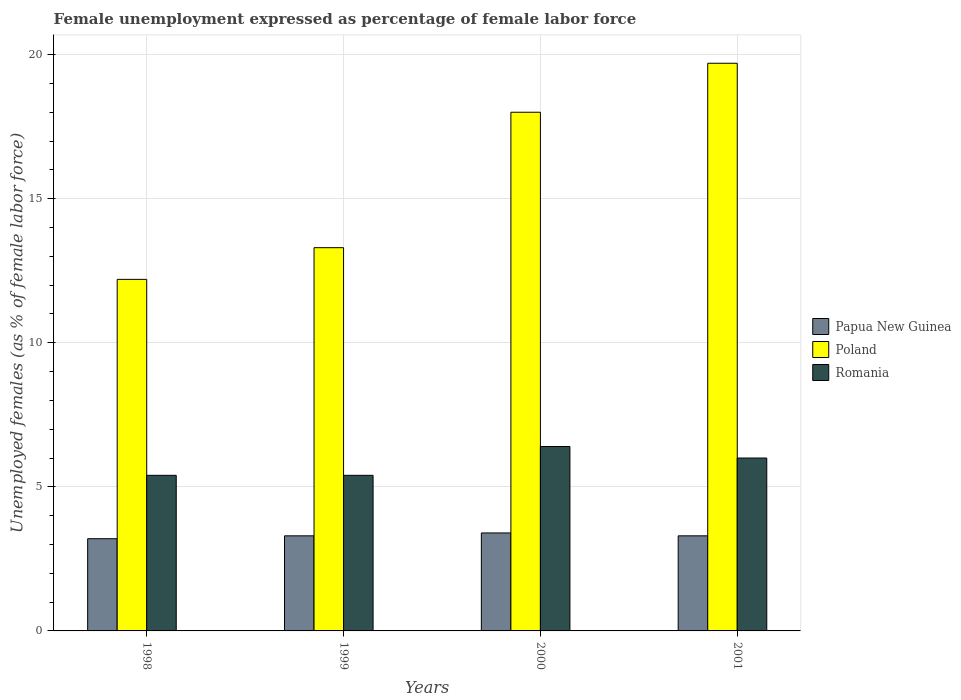How many different coloured bars are there?
Keep it short and to the point. 3. How many groups of bars are there?
Provide a succinct answer. 4. Are the number of bars on each tick of the X-axis equal?
Offer a very short reply. Yes. How many bars are there on the 2nd tick from the right?
Your answer should be very brief. 3. What is the label of the 1st group of bars from the left?
Give a very brief answer. 1998. In how many cases, is the number of bars for a given year not equal to the number of legend labels?
Your response must be concise. 0. What is the unemployment in females in in Papua New Guinea in 2001?
Your response must be concise. 3.3. Across all years, what is the maximum unemployment in females in in Romania?
Provide a short and direct response. 6.4. Across all years, what is the minimum unemployment in females in in Poland?
Offer a terse response. 12.2. In which year was the unemployment in females in in Romania maximum?
Ensure brevity in your answer.  2000. In which year was the unemployment in females in in Papua New Guinea minimum?
Provide a short and direct response. 1998. What is the total unemployment in females in in Papua New Guinea in the graph?
Offer a terse response. 13.2. What is the difference between the unemployment in females in in Romania in 1999 and that in 2001?
Your answer should be very brief. -0.6. What is the difference between the unemployment in females in in Romania in 1998 and the unemployment in females in in Papua New Guinea in 1999?
Provide a succinct answer. 2.1. What is the average unemployment in females in in Poland per year?
Give a very brief answer. 15.8. In the year 1999, what is the difference between the unemployment in females in in Poland and unemployment in females in in Papua New Guinea?
Provide a succinct answer. 10. What is the ratio of the unemployment in females in in Papua New Guinea in 1999 to that in 2000?
Keep it short and to the point. 0.97. Is the unemployment in females in in Poland in 1998 less than that in 1999?
Ensure brevity in your answer.  Yes. What is the difference between the highest and the second highest unemployment in females in in Poland?
Your response must be concise. 1.7. What is the difference between the highest and the lowest unemployment in females in in Romania?
Make the answer very short. 1. In how many years, is the unemployment in females in in Papua New Guinea greater than the average unemployment in females in in Papua New Guinea taken over all years?
Make the answer very short. 1. Is the sum of the unemployment in females in in Papua New Guinea in 2000 and 2001 greater than the maximum unemployment in females in in Romania across all years?
Provide a short and direct response. Yes. What does the 2nd bar from the left in 1999 represents?
Provide a succinct answer. Poland. What does the 1st bar from the right in 1998 represents?
Your response must be concise. Romania. What is the difference between two consecutive major ticks on the Y-axis?
Give a very brief answer. 5. Where does the legend appear in the graph?
Provide a short and direct response. Center right. How are the legend labels stacked?
Offer a very short reply. Vertical. What is the title of the graph?
Your response must be concise. Female unemployment expressed as percentage of female labor force. What is the label or title of the X-axis?
Provide a succinct answer. Years. What is the label or title of the Y-axis?
Your response must be concise. Unemployed females (as % of female labor force). What is the Unemployed females (as % of female labor force) of Papua New Guinea in 1998?
Provide a succinct answer. 3.2. What is the Unemployed females (as % of female labor force) in Poland in 1998?
Provide a short and direct response. 12.2. What is the Unemployed females (as % of female labor force) in Romania in 1998?
Your answer should be compact. 5.4. What is the Unemployed females (as % of female labor force) of Papua New Guinea in 1999?
Ensure brevity in your answer.  3.3. What is the Unemployed females (as % of female labor force) in Poland in 1999?
Offer a very short reply. 13.3. What is the Unemployed females (as % of female labor force) in Romania in 1999?
Make the answer very short. 5.4. What is the Unemployed females (as % of female labor force) of Papua New Guinea in 2000?
Your answer should be compact. 3.4. What is the Unemployed females (as % of female labor force) in Romania in 2000?
Give a very brief answer. 6.4. What is the Unemployed females (as % of female labor force) in Papua New Guinea in 2001?
Offer a very short reply. 3.3. What is the Unemployed females (as % of female labor force) of Poland in 2001?
Give a very brief answer. 19.7. What is the Unemployed females (as % of female labor force) of Romania in 2001?
Provide a short and direct response. 6. Across all years, what is the maximum Unemployed females (as % of female labor force) in Papua New Guinea?
Your answer should be compact. 3.4. Across all years, what is the maximum Unemployed females (as % of female labor force) of Poland?
Provide a short and direct response. 19.7. Across all years, what is the maximum Unemployed females (as % of female labor force) in Romania?
Your response must be concise. 6.4. Across all years, what is the minimum Unemployed females (as % of female labor force) of Papua New Guinea?
Ensure brevity in your answer.  3.2. Across all years, what is the minimum Unemployed females (as % of female labor force) of Poland?
Your answer should be very brief. 12.2. Across all years, what is the minimum Unemployed females (as % of female labor force) in Romania?
Your answer should be compact. 5.4. What is the total Unemployed females (as % of female labor force) of Papua New Guinea in the graph?
Your answer should be compact. 13.2. What is the total Unemployed females (as % of female labor force) of Poland in the graph?
Your response must be concise. 63.2. What is the total Unemployed females (as % of female labor force) of Romania in the graph?
Provide a short and direct response. 23.2. What is the difference between the Unemployed females (as % of female labor force) in Papua New Guinea in 1998 and that in 1999?
Provide a short and direct response. -0.1. What is the difference between the Unemployed females (as % of female labor force) in Poland in 1998 and that in 1999?
Ensure brevity in your answer.  -1.1. What is the difference between the Unemployed females (as % of female labor force) in Papua New Guinea in 1998 and that in 2000?
Offer a very short reply. -0.2. What is the difference between the Unemployed females (as % of female labor force) in Poland in 1998 and that in 2000?
Provide a short and direct response. -5.8. What is the difference between the Unemployed females (as % of female labor force) in Papua New Guinea in 1998 and that in 2001?
Make the answer very short. -0.1. What is the difference between the Unemployed females (as % of female labor force) of Poland in 1998 and that in 2001?
Provide a short and direct response. -7.5. What is the difference between the Unemployed females (as % of female labor force) of Romania in 1998 and that in 2001?
Offer a very short reply. -0.6. What is the difference between the Unemployed females (as % of female labor force) in Papua New Guinea in 1999 and that in 2000?
Ensure brevity in your answer.  -0.1. What is the difference between the Unemployed females (as % of female labor force) in Papua New Guinea in 1999 and that in 2001?
Your answer should be compact. 0. What is the difference between the Unemployed females (as % of female labor force) of Poland in 1999 and that in 2001?
Offer a terse response. -6.4. What is the difference between the Unemployed females (as % of female labor force) of Romania in 1999 and that in 2001?
Keep it short and to the point. -0.6. What is the difference between the Unemployed females (as % of female labor force) in Papua New Guinea in 2000 and that in 2001?
Your answer should be very brief. 0.1. What is the difference between the Unemployed females (as % of female labor force) of Poland in 1998 and the Unemployed females (as % of female labor force) of Romania in 1999?
Provide a succinct answer. 6.8. What is the difference between the Unemployed females (as % of female labor force) of Papua New Guinea in 1998 and the Unemployed females (as % of female labor force) of Poland in 2000?
Your response must be concise. -14.8. What is the difference between the Unemployed females (as % of female labor force) in Papua New Guinea in 1998 and the Unemployed females (as % of female labor force) in Poland in 2001?
Keep it short and to the point. -16.5. What is the difference between the Unemployed females (as % of female labor force) in Poland in 1998 and the Unemployed females (as % of female labor force) in Romania in 2001?
Provide a succinct answer. 6.2. What is the difference between the Unemployed females (as % of female labor force) of Papua New Guinea in 1999 and the Unemployed females (as % of female labor force) of Poland in 2000?
Offer a terse response. -14.7. What is the difference between the Unemployed females (as % of female labor force) of Papua New Guinea in 1999 and the Unemployed females (as % of female labor force) of Romania in 2000?
Make the answer very short. -3.1. What is the difference between the Unemployed females (as % of female labor force) in Poland in 1999 and the Unemployed females (as % of female labor force) in Romania in 2000?
Make the answer very short. 6.9. What is the difference between the Unemployed females (as % of female labor force) of Papua New Guinea in 1999 and the Unemployed females (as % of female labor force) of Poland in 2001?
Your answer should be very brief. -16.4. What is the difference between the Unemployed females (as % of female labor force) in Papua New Guinea in 1999 and the Unemployed females (as % of female labor force) in Romania in 2001?
Provide a short and direct response. -2.7. What is the difference between the Unemployed females (as % of female labor force) of Papua New Guinea in 2000 and the Unemployed females (as % of female labor force) of Poland in 2001?
Offer a very short reply. -16.3. What is the average Unemployed females (as % of female labor force) in Poland per year?
Keep it short and to the point. 15.8. What is the average Unemployed females (as % of female labor force) in Romania per year?
Your answer should be very brief. 5.8. In the year 1998, what is the difference between the Unemployed females (as % of female labor force) of Papua New Guinea and Unemployed females (as % of female labor force) of Romania?
Give a very brief answer. -2.2. In the year 2000, what is the difference between the Unemployed females (as % of female labor force) of Papua New Guinea and Unemployed females (as % of female labor force) of Poland?
Your response must be concise. -14.6. In the year 2000, what is the difference between the Unemployed females (as % of female labor force) of Papua New Guinea and Unemployed females (as % of female labor force) of Romania?
Make the answer very short. -3. In the year 2000, what is the difference between the Unemployed females (as % of female labor force) in Poland and Unemployed females (as % of female labor force) in Romania?
Keep it short and to the point. 11.6. In the year 2001, what is the difference between the Unemployed females (as % of female labor force) in Papua New Guinea and Unemployed females (as % of female labor force) in Poland?
Give a very brief answer. -16.4. What is the ratio of the Unemployed females (as % of female labor force) of Papua New Guinea in 1998 to that in 1999?
Make the answer very short. 0.97. What is the ratio of the Unemployed females (as % of female labor force) of Poland in 1998 to that in 1999?
Provide a succinct answer. 0.92. What is the ratio of the Unemployed females (as % of female labor force) in Romania in 1998 to that in 1999?
Your answer should be very brief. 1. What is the ratio of the Unemployed females (as % of female labor force) in Papua New Guinea in 1998 to that in 2000?
Provide a succinct answer. 0.94. What is the ratio of the Unemployed females (as % of female labor force) of Poland in 1998 to that in 2000?
Offer a very short reply. 0.68. What is the ratio of the Unemployed females (as % of female labor force) in Romania in 1998 to that in 2000?
Provide a short and direct response. 0.84. What is the ratio of the Unemployed females (as % of female labor force) of Papua New Guinea in 1998 to that in 2001?
Keep it short and to the point. 0.97. What is the ratio of the Unemployed females (as % of female labor force) of Poland in 1998 to that in 2001?
Offer a very short reply. 0.62. What is the ratio of the Unemployed females (as % of female labor force) in Romania in 1998 to that in 2001?
Give a very brief answer. 0.9. What is the ratio of the Unemployed females (as % of female labor force) of Papua New Guinea in 1999 to that in 2000?
Offer a very short reply. 0.97. What is the ratio of the Unemployed females (as % of female labor force) of Poland in 1999 to that in 2000?
Give a very brief answer. 0.74. What is the ratio of the Unemployed females (as % of female labor force) of Romania in 1999 to that in 2000?
Provide a short and direct response. 0.84. What is the ratio of the Unemployed females (as % of female labor force) in Papua New Guinea in 1999 to that in 2001?
Keep it short and to the point. 1. What is the ratio of the Unemployed females (as % of female labor force) of Poland in 1999 to that in 2001?
Provide a short and direct response. 0.68. What is the ratio of the Unemployed females (as % of female labor force) of Romania in 1999 to that in 2001?
Make the answer very short. 0.9. What is the ratio of the Unemployed females (as % of female labor force) of Papua New Guinea in 2000 to that in 2001?
Offer a very short reply. 1.03. What is the ratio of the Unemployed females (as % of female labor force) of Poland in 2000 to that in 2001?
Provide a succinct answer. 0.91. What is the ratio of the Unemployed females (as % of female labor force) in Romania in 2000 to that in 2001?
Your response must be concise. 1.07. What is the difference between the highest and the second highest Unemployed females (as % of female labor force) in Poland?
Make the answer very short. 1.7. What is the difference between the highest and the lowest Unemployed females (as % of female labor force) of Papua New Guinea?
Offer a very short reply. 0.2. What is the difference between the highest and the lowest Unemployed females (as % of female labor force) in Romania?
Provide a succinct answer. 1. 